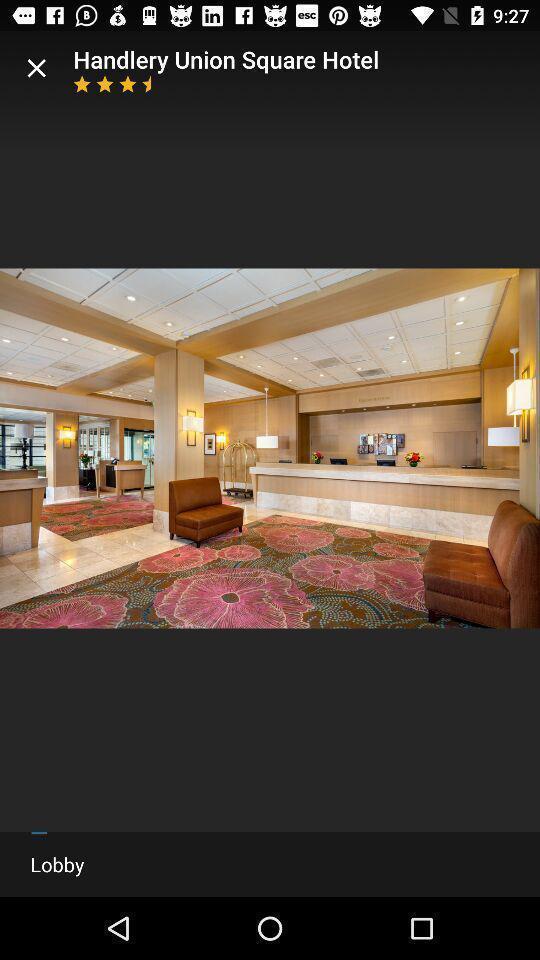Describe the visual elements of this screenshot. Page displaying with a image of a hotel lobby. 